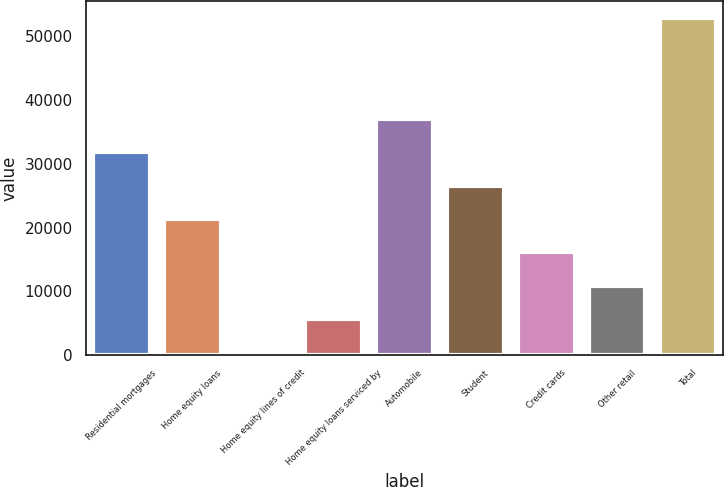Convert chart. <chart><loc_0><loc_0><loc_500><loc_500><bar_chart><fcel>Residential mortgages<fcel>Home equity loans<fcel>Home equity lines of credit<fcel>Home equity loans serviced by<fcel>Automobile<fcel>Student<fcel>Credit cards<fcel>Other retail<fcel>Total<nl><fcel>31852.4<fcel>21364.6<fcel>389<fcel>5632.9<fcel>37096.3<fcel>26608.5<fcel>16120.7<fcel>10876.8<fcel>52828<nl></chart> 